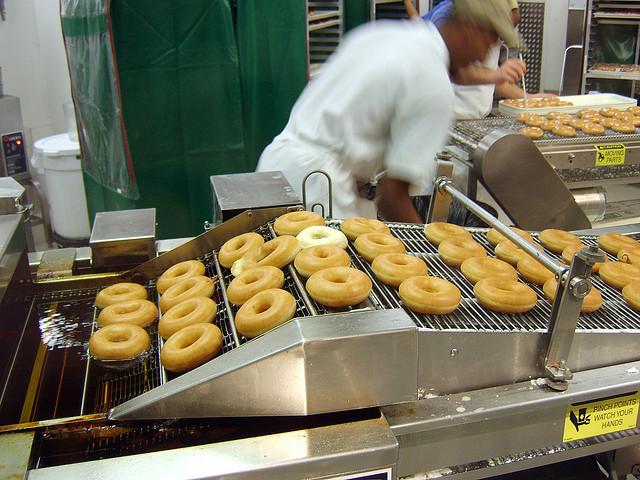What pastry is being made?
Write a very short answer. Donuts. Where is the trash can?
Concise answer only. Back left. Is this an example of an assembly line?
Concise answer only. Yes. 